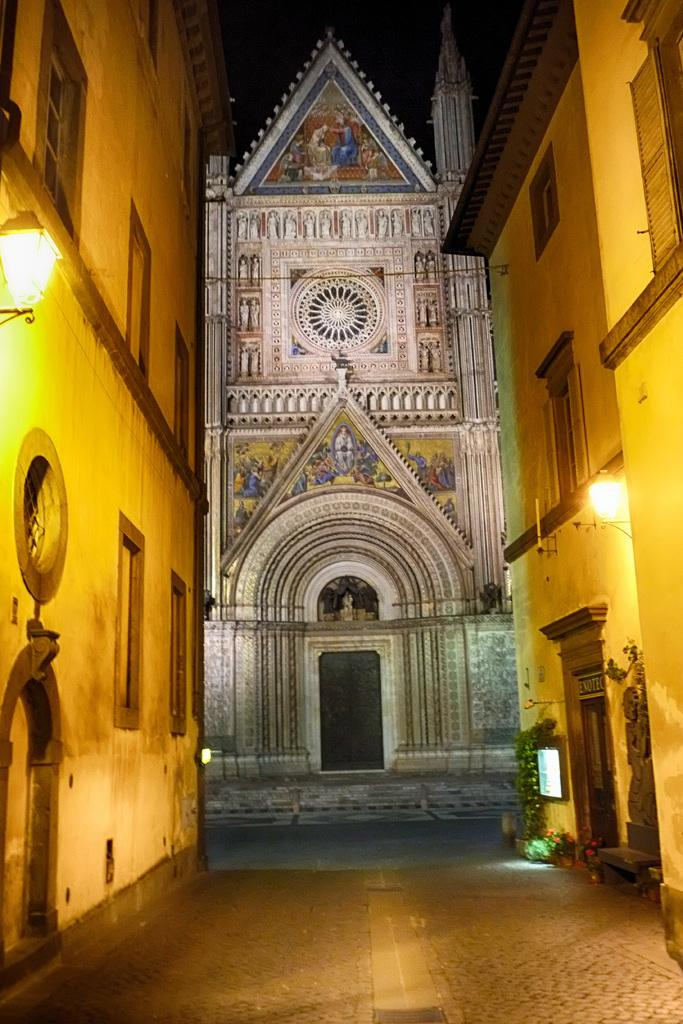What type of structures are present in the image? There are buildings in the image. Can you describe any additional features of the buildings? Lights are attached to the walls of the buildings. How many oranges are being used to fuel the kettle in the image? There are no oranges or kettles present in the image. What type of battle is taking place in the image? There is no battle depicted in the image; it features buildings with lights attached to their walls. 